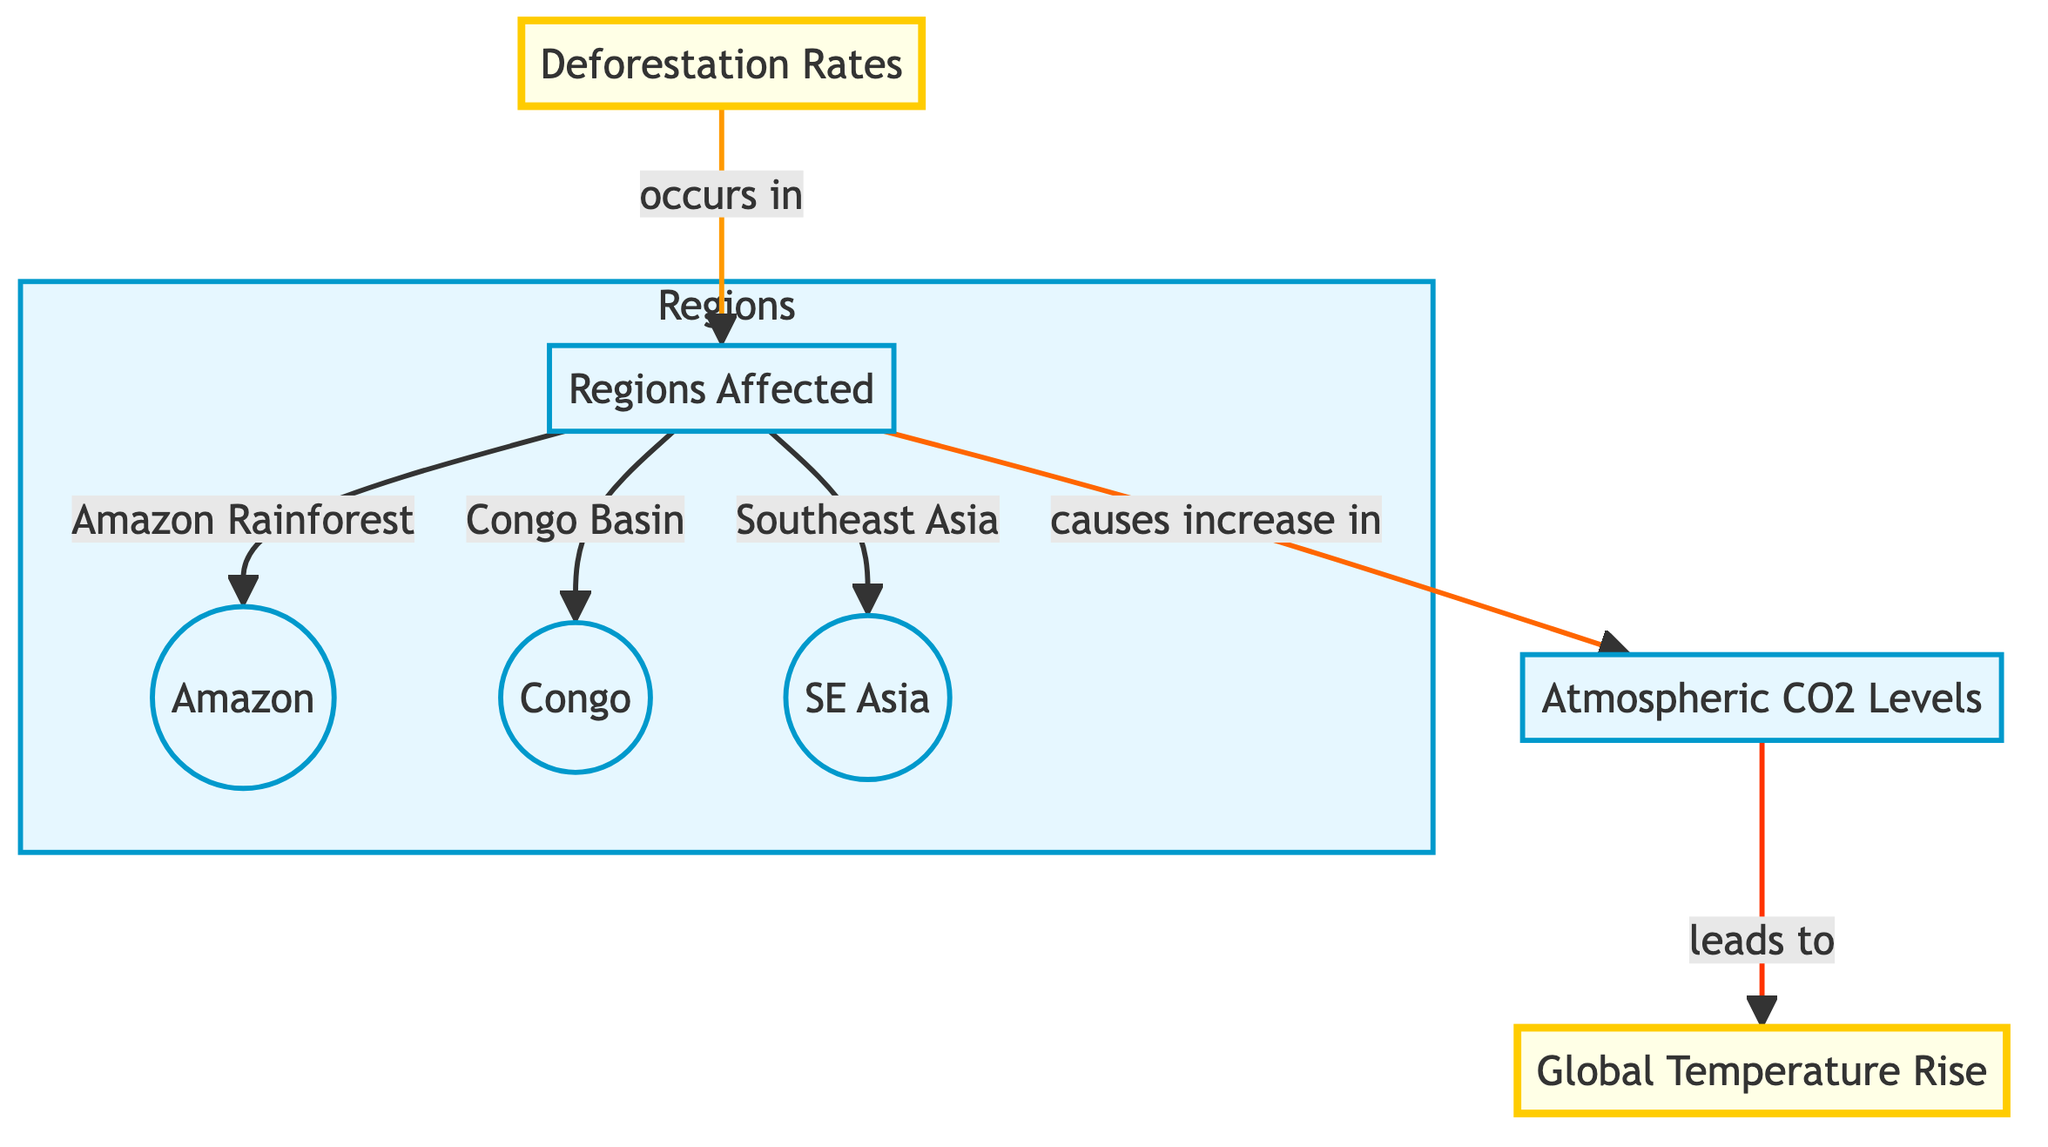What are the regions affected by deforestation? By examining the diagram, the regions specifically mentioned under the "Regions Affected" node are the Amazon Rainforest, the Congo Basin, and Southeast Asia. These are indicated by the flow connections leading from "Regions Affected" to the respective areas.
Answer: Amazon Rainforest, Congo Basin, Southeast Asia What does deforestation cause an increase in? The diagram indicates that deforestation leads directly to an increase in atmospheric CO2 levels, specifically shown by the arrow pointing from "Deforestation Rates" to "Atmospheric CO2 Levels."
Answer: Atmospheric CO2 Levels What effect does atmospheric CO2 have on global temperatures? According to the diagram, atmospheric CO2 levels lead to an increase in global temperatures. This relationship is illustrated with an arrow connecting "Atmospheric CO2 Levels" to "Global Temperature Rise."
Answer: Global Temperature Rise How many regions are affected according to the diagram? The diagram lists three regions specifically affected by deforestation: Amazon Rainforest, Congo Basin, and Southeast Asia. Therefore, upon counting these regions, the total is three.
Answer: 3 What is the main pathway of impact shown in the diagram? The diagram provides a clear directional flow: deforestation rates lead to regions affected, which subsequently increase atmospheric CO2 levels, ultimately causing global temperature rise. The pathway follows the arrows from one node to the next.
Answer: Deforestation Rates → Regions Affected → Atmospheric CO2 Levels → Global Temperature Rise Which node is emphasized in the diagram? The nodes that are emphasized in the diagram are "Deforestation Rates" and "Global Temperature Rise," as indicated by the use of the emphasis class, which is usually represented by different coloring and stroke styles in flowcharts.
Answer: Deforestation Rates, Global Temperature Rise 